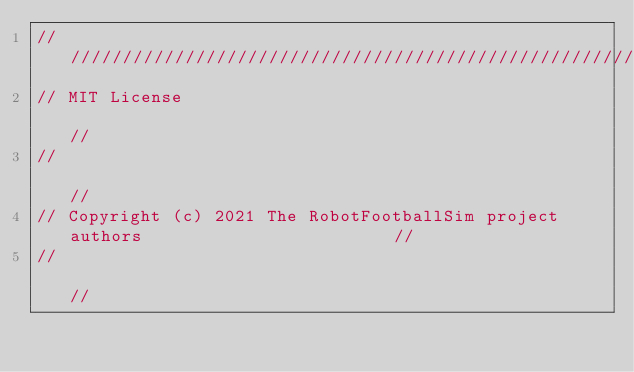Convert code to text. <code><loc_0><loc_0><loc_500><loc_500><_C++_>////////////////////////////////////////////////////////////////////////////////////
// MIT License                                                                    //
//                                                                                //
// Copyright (c) 2021 The RobotFootballSim project authors                        //
//                                                                                //</code> 